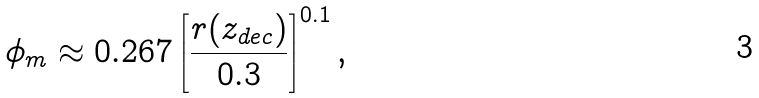Convert formula to latex. <formula><loc_0><loc_0><loc_500><loc_500>\phi _ { m } \approx 0 . 2 6 7 \left [ \frac { r ( z _ { d e c } ) } { 0 . 3 } \right ] ^ { 0 . 1 } ,</formula> 